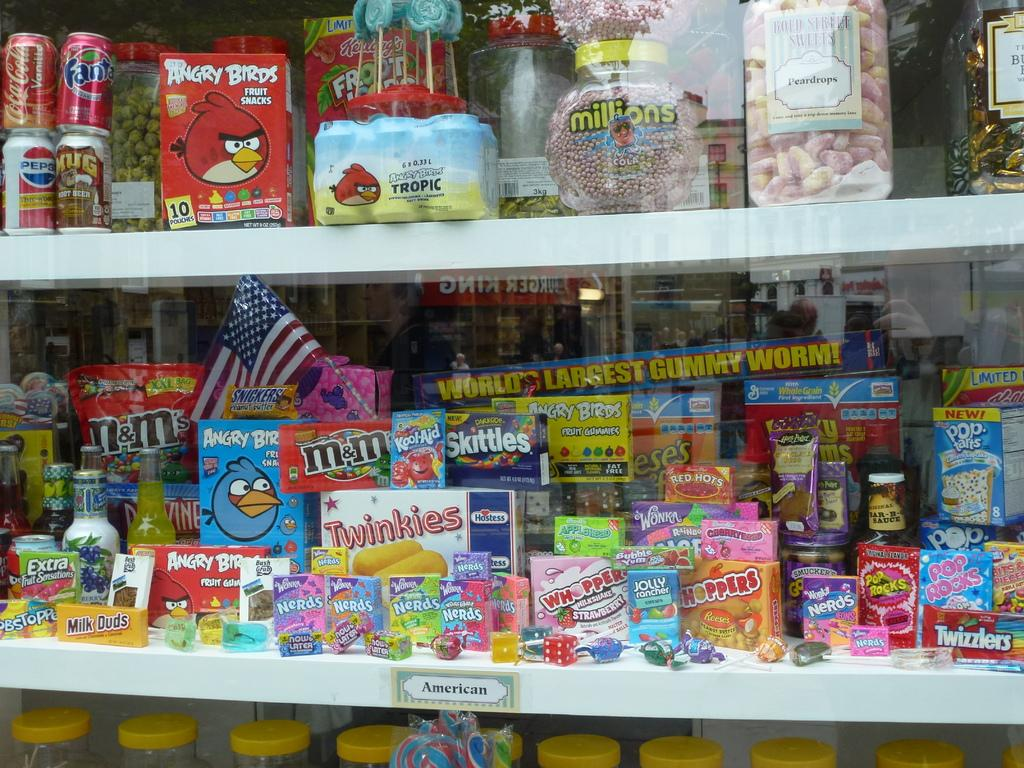<image>
Share a concise interpretation of the image provided. a store display for candies like World's Largest Gummy Worm 